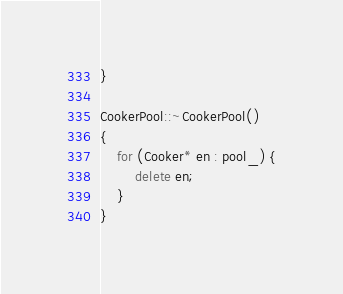Convert code to text. <code><loc_0><loc_0><loc_500><loc_500><_C++_>}

CookerPool::~CookerPool()
{
	for (Cooker* en : pool_) {
		delete en;
	}
}</code> 